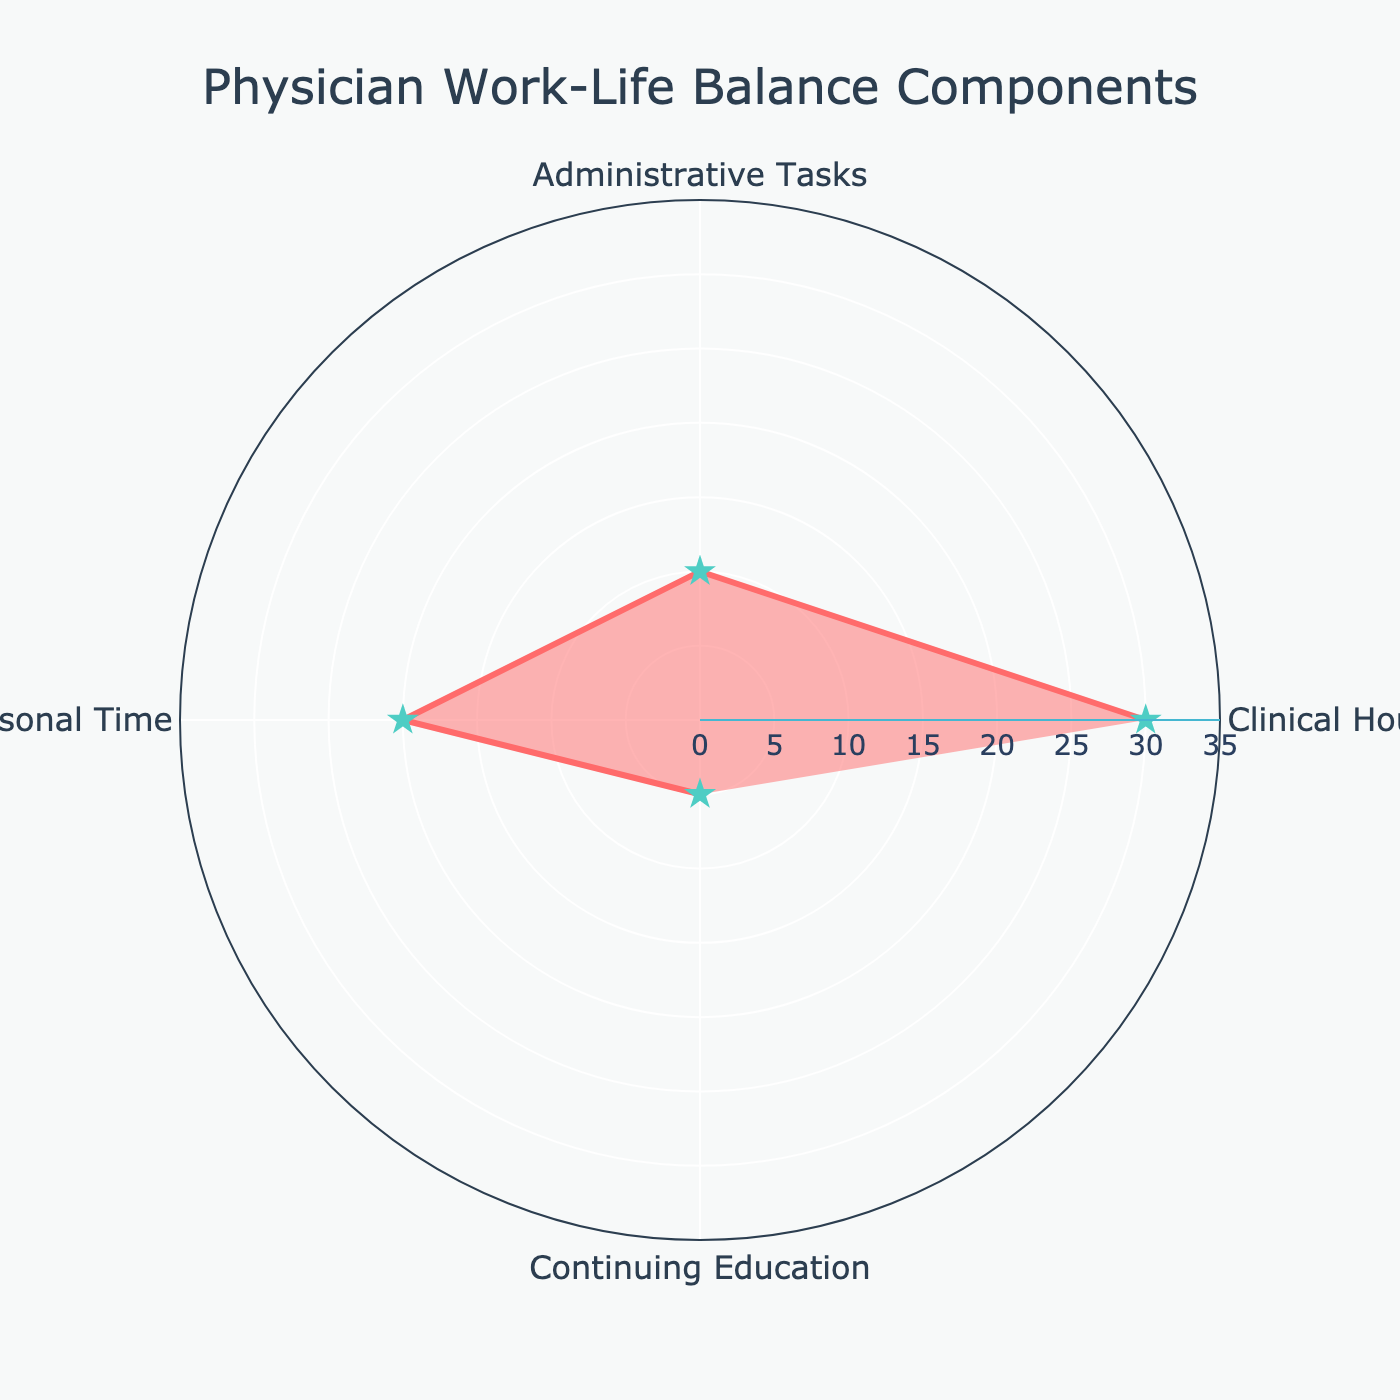What's the title of the figure? The title appears at the top of the figure, describing its subject. In this case, it is "Physician Work-Life Balance Components".
Answer: Physician Work-Life Balance Components What are the four categories displayed in the chart? The categories are listed on the angular axis of the polar chart and include: Clinical Hours, Administrative Tasks, Personal Time, and Continuing Education.
Answer: Clinical Hours, Administrative Tasks, Personal Time, Continuing Education Which category has the highest number of hours per week? The category with the highest data point in the polar chart would have the longest radial distance. Clinical Hours has the longest radial distance indicating the highest number of hours at 30.
Answer: Clinical Hours How many hours per week are dedicated to continuing education? By looking at the segment labeled Continuing Education on the polar chart, it shows a radial distance corresponding to 5 hours per week.
Answer: 5 Compare the number of hours for Clinical Hours and Personal Time. Which one is higher? Observing the radial distances for Clinical Hours and Personal Time shows that Clinical Hours has a distance of 30, while Personal Time has 20. Therefore, Clinical Hours is higher.
Answer: Clinical Hours What is the total number of hours per week shown in the chart? To find the total, sum all the hourly values from each category. Clinical Hours (30) + Administrative Tasks (10) + Personal Time (20) + Continuing Education (5) = 65
Answer: 65 How many more hours are spent on Clinical Hours compared to Administrative Tasks? Subtract Administrative Tasks (10) from Clinical Hours (30) to find the difference: 30 - 10 = 20
Answer: 20 What is the average number of hours spent across all categories? Sum the total hours and divide by the number of categories. The total hours are 65 (as calculated before), and there are 4 categories. Thus, 65 ÷ 4 = 16.25
Answer: 16.25 Which two categories have the closest number of hours per week? Examining the chart visually indicates that Administrative Tasks (10) and Continuing Education (5) have the closest number of hours, with a difference of 5.
Answer: Administrative Tasks and Continuing Education If the hours for Personal Time were doubled, what would be the new radial distance for that category on the chart? Doubling Personal Time, which is currently at 20 hours, would result in 20 × 2 = 40 hours. Thus, the new radial distance would be 40.
Answer: 40 